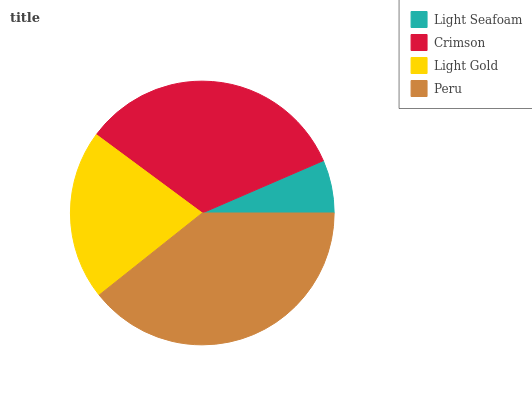Is Light Seafoam the minimum?
Answer yes or no. Yes. Is Peru the maximum?
Answer yes or no. Yes. Is Crimson the minimum?
Answer yes or no. No. Is Crimson the maximum?
Answer yes or no. No. Is Crimson greater than Light Seafoam?
Answer yes or no. Yes. Is Light Seafoam less than Crimson?
Answer yes or no. Yes. Is Light Seafoam greater than Crimson?
Answer yes or no. No. Is Crimson less than Light Seafoam?
Answer yes or no. No. Is Crimson the high median?
Answer yes or no. Yes. Is Light Gold the low median?
Answer yes or no. Yes. Is Peru the high median?
Answer yes or no. No. Is Crimson the low median?
Answer yes or no. No. 